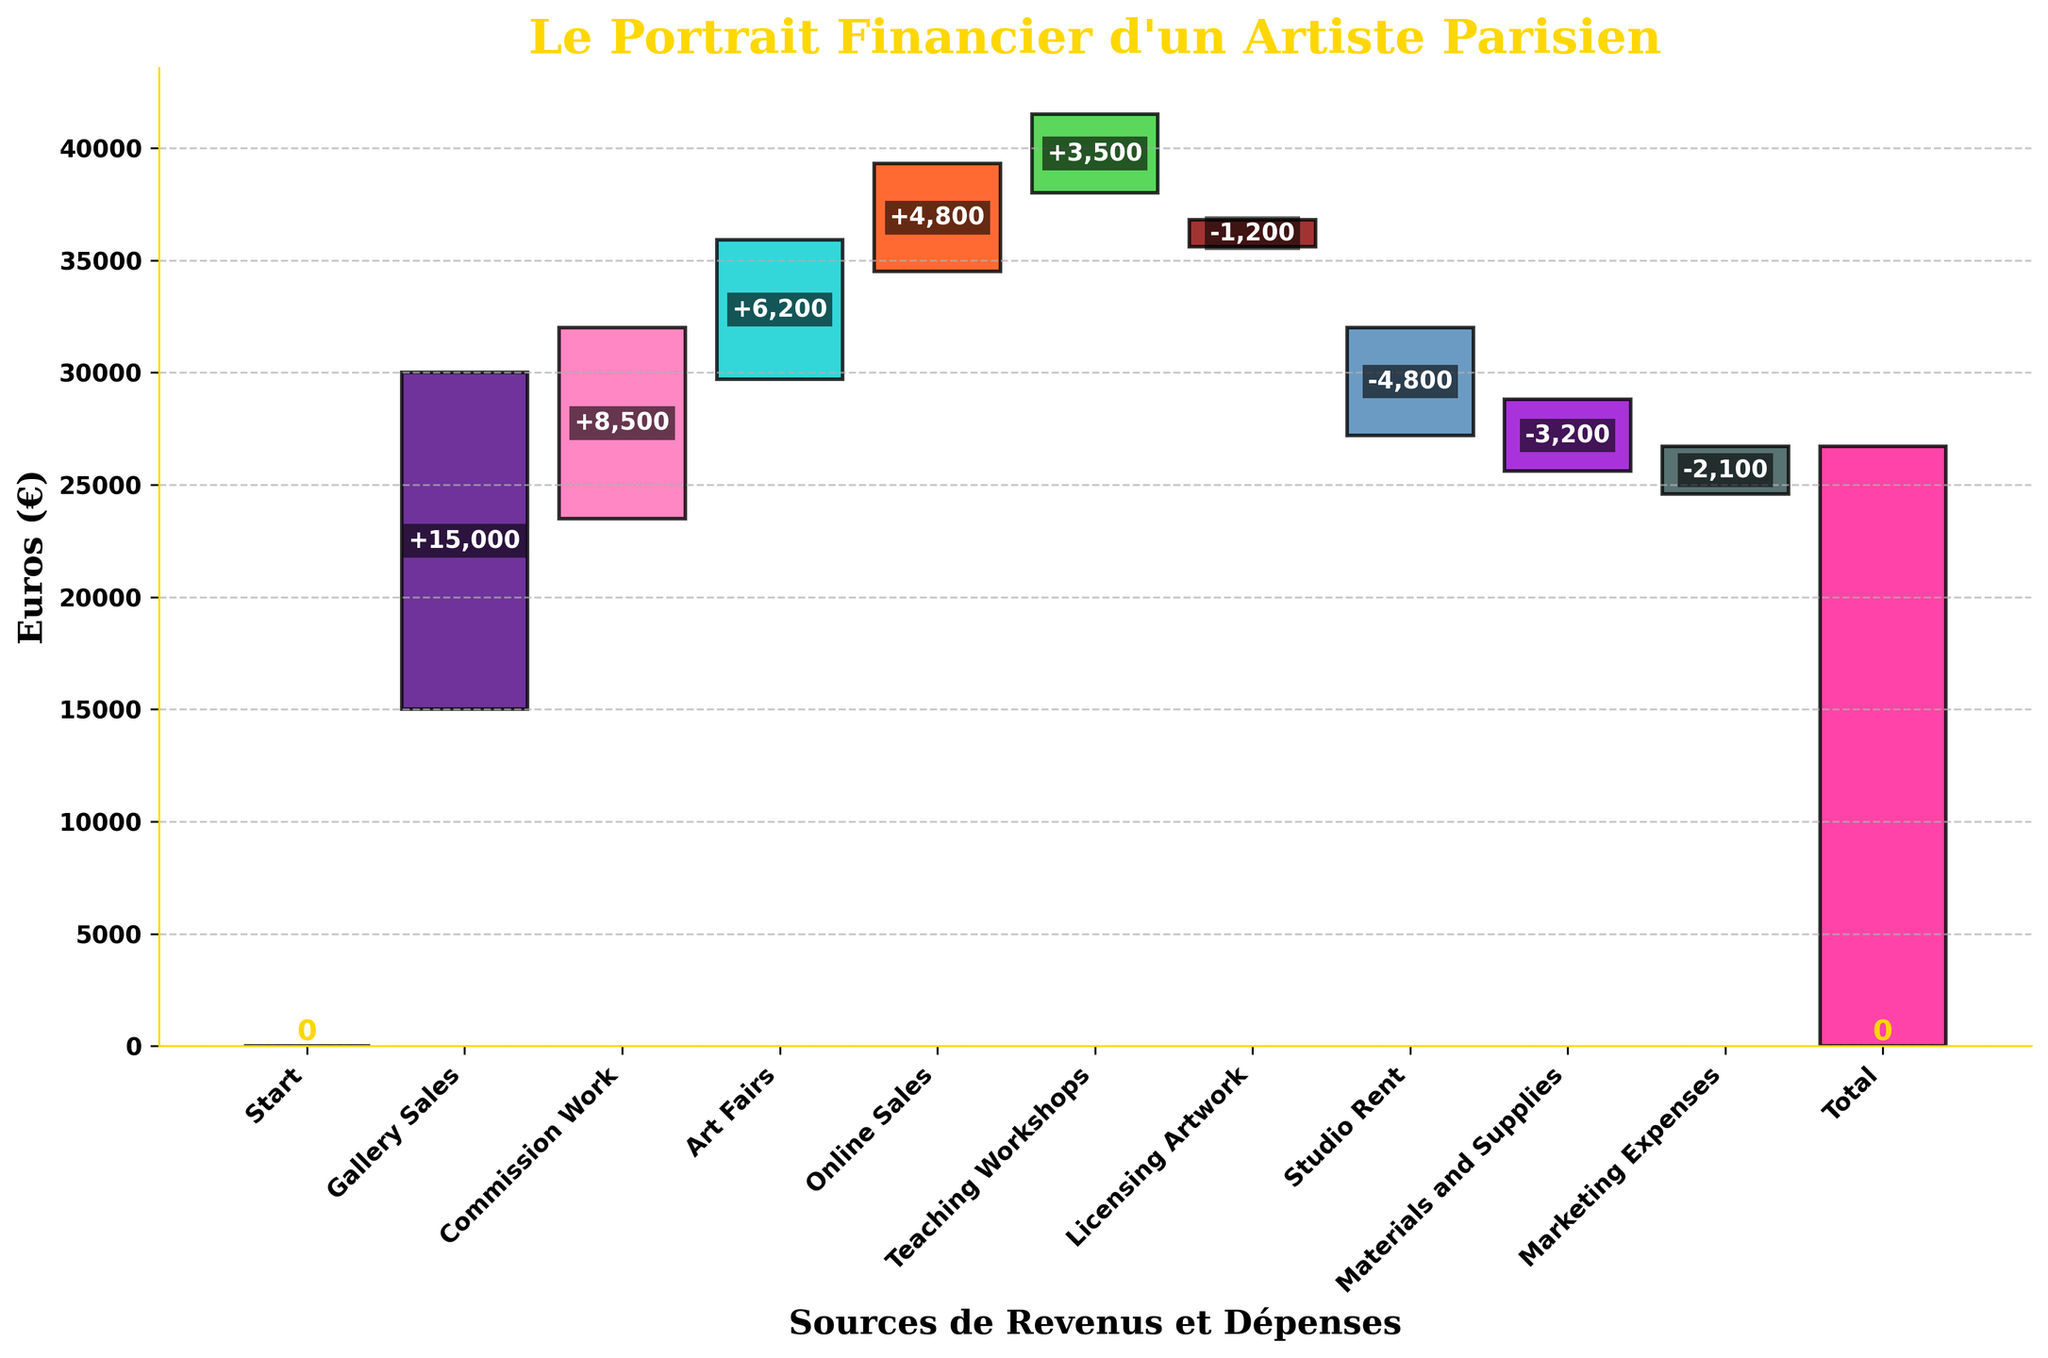What is the title of the chart? The title is usually the large text at the top of the chart. Here, it says "Le Portrait Financier d'un Artiste Parisien".
Answer: Le Portrait Financier d'un Artiste Parisien What is the total income displayed in the chart? The total income is shown at the last bar, labeled "Total". It indicates the final net value after all income sources and expenses are considered.
Answer: 26700 Which revenue source contributes the most to the artist's income? By comparing the heights of the positive values, we see that "Gallery Sales" is the highest, contributing 15000 Euros.
Answer: Gallery Sales How much does the artist earn from Commission Work and Online Sales combined? Sum the values of "Commission Work" (8500) and "Online Sales" (4800). 8500 + 4800 = 13300.
Answer: 13300 What are the expenses listed in the chart and their combined total? The expenses are "Licensing Artwork" (-1200), "Studio Rent" (-4800), "Materials and Supplies" (-3200), and "Marketing Expenses" (-2100). Sum these values to get the combined total: -1200 + (-4800) + (-3200) + (-2100) = -11300.
Answer: -11300 How does the total income change after considering Studio Rent? Start from the cumulative income before Studio Rent, then subtract the expense of Studio Rent (4800) from it. The cumulative income before Studio Rent can be deduced from the bars or directly examined in the chart. Assuming it's correctly read as 24500 before Studio Rent, then 24500 - 4800 = 19700.
Answer: 19700 By how much do the total earnings from Gallery Sales and Art Fairs exceed the earnings from Teaching Workshops? Calculate the sum of "Gallery Sales" (15000) and "Art Fairs" (6200), then subtract "Teaching Workshops" (3500). 15000 + 6200 - 3500 = 17700.
Answer: 17700 Which expense has the least negative impact on the artist's income? Compare the absolute values of the negative contributions. "Licensing Artwork" has the smallest value of -1200 Euros.
Answer: Licensing Artwork How much would the total income be if Licensing Artwork had no impact (value of 0)? Currently, Licensing Artwork contributes -1200. If it were 0, the total would be 26700 + 1200 = 27900.
Answer: 27900 Which color is used to highlight the net final total in the chart? The final net total is emphasized in the chart, often with a distinct color. Here, the bar is highlighted in gold/yellow.
Answer: Gold/yellow 